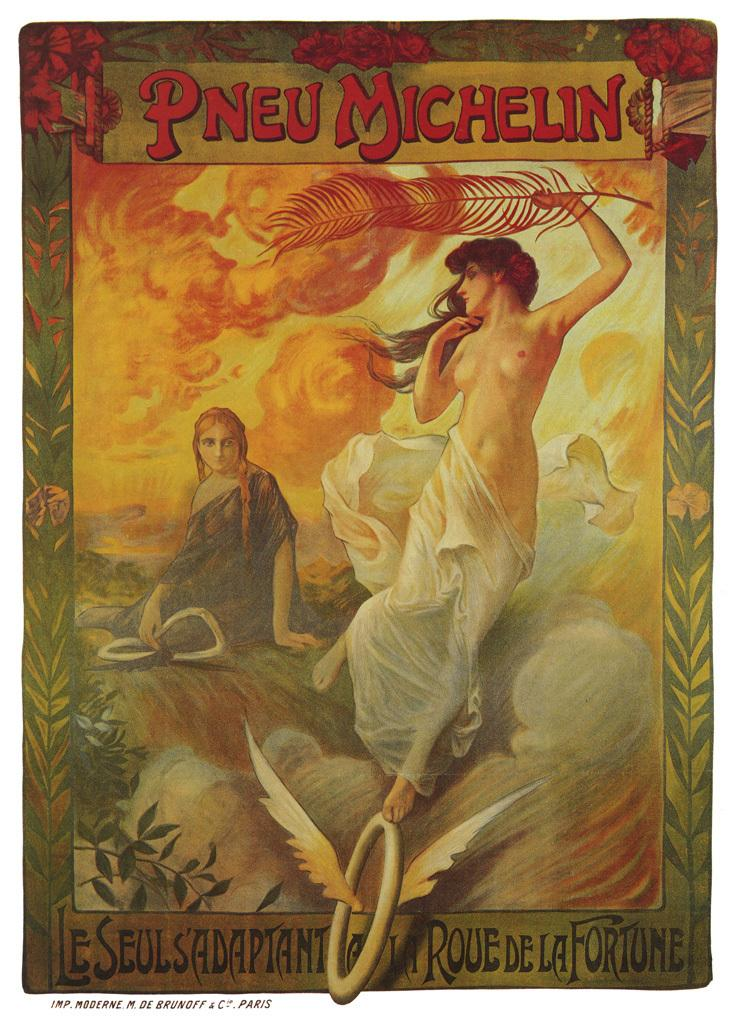How many people are in the image? There are two women depicted in the image. What can be seen in addition to the women in the image? There is writing present in the image at a few places. What type of knee is visible in the image? There is no knee visible in the image; it only features two women and writing. 